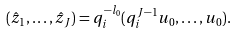<formula> <loc_0><loc_0><loc_500><loc_500>( \hat { z } _ { 1 } , \dots , \hat { z } _ { J } ) = q _ { i } ^ { - l _ { 0 } } ( q _ { i } ^ { J - 1 } u _ { 0 } , \dots , u _ { 0 } ) .</formula> 